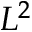Convert formula to latex. <formula><loc_0><loc_0><loc_500><loc_500>L ^ { 2 }</formula> 